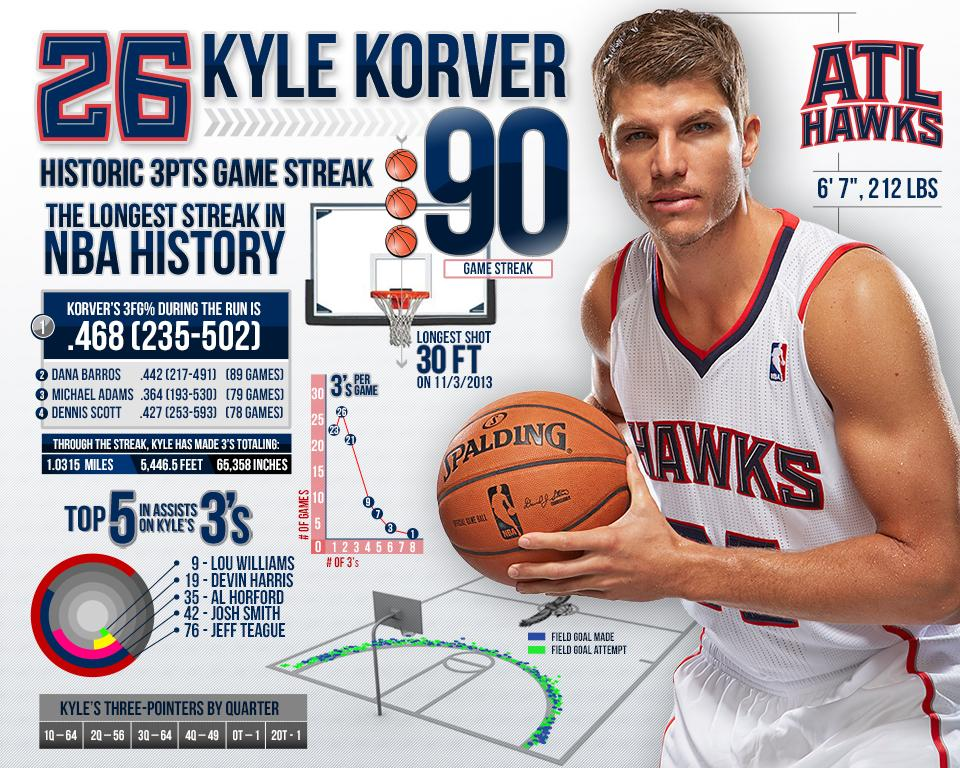Mention a couple of crucial points in this snapshot. Kyle Korver had a game streak where he scored 90 points, which was his highest game streak. He is 6'7". It is Dana Barros who had the second highest 3-point field goal percentage. Kyle Korver wears jersey number 26 for his team. He made 64 three-pointers in the first quarter. 